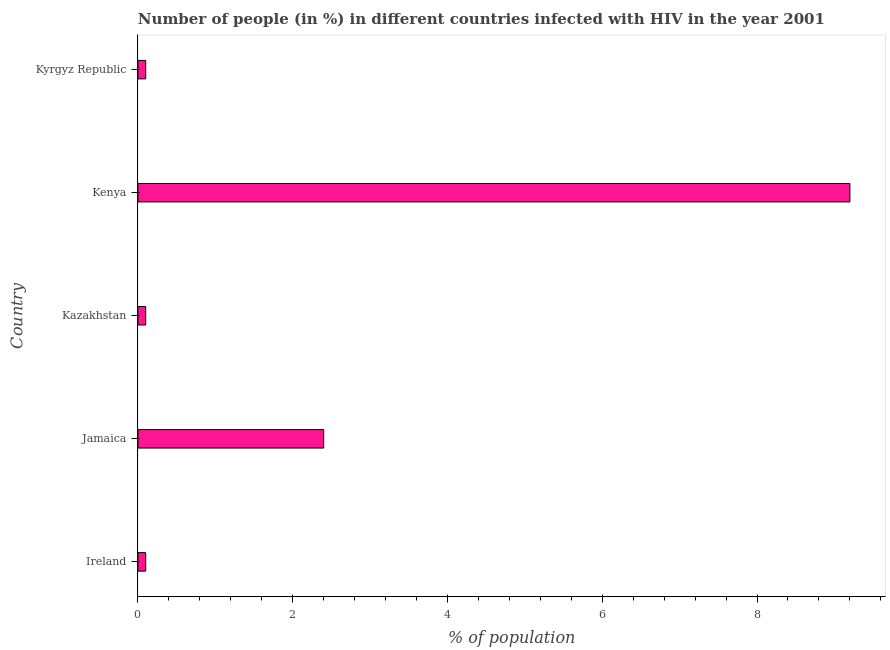What is the title of the graph?
Ensure brevity in your answer.  Number of people (in %) in different countries infected with HIV in the year 2001. What is the label or title of the X-axis?
Make the answer very short. % of population. What is the label or title of the Y-axis?
Make the answer very short. Country. What is the number of people infected with hiv in Kenya?
Your answer should be very brief. 9.2. Across all countries, what is the maximum number of people infected with hiv?
Ensure brevity in your answer.  9.2. In which country was the number of people infected with hiv maximum?
Your answer should be very brief. Kenya. In which country was the number of people infected with hiv minimum?
Give a very brief answer. Ireland. What is the sum of the number of people infected with hiv?
Offer a terse response. 11.9. What is the difference between the number of people infected with hiv in Ireland and Kazakhstan?
Your answer should be very brief. 0. What is the average number of people infected with hiv per country?
Offer a very short reply. 2.38. What is the median number of people infected with hiv?
Your response must be concise. 0.1. In how many countries, is the number of people infected with hiv greater than 5.6 %?
Provide a short and direct response. 1. What is the ratio of the number of people infected with hiv in Jamaica to that in Kazakhstan?
Your answer should be compact. 24. Is the difference between the number of people infected with hiv in Jamaica and Kyrgyz Republic greater than the difference between any two countries?
Make the answer very short. No. What is the difference between the highest and the second highest number of people infected with hiv?
Ensure brevity in your answer.  6.8. What is the difference between the highest and the lowest number of people infected with hiv?
Your response must be concise. 9.1. How many countries are there in the graph?
Provide a short and direct response. 5. What is the difference between two consecutive major ticks on the X-axis?
Your answer should be very brief. 2. What is the % of population of Ireland?
Your response must be concise. 0.1. What is the % of population of Kenya?
Give a very brief answer. 9.2. What is the % of population in Kyrgyz Republic?
Provide a short and direct response. 0.1. What is the difference between the % of population in Ireland and Kyrgyz Republic?
Ensure brevity in your answer.  0. What is the difference between the % of population in Jamaica and Kenya?
Offer a terse response. -6.8. What is the difference between the % of population in Jamaica and Kyrgyz Republic?
Make the answer very short. 2.3. What is the ratio of the % of population in Ireland to that in Jamaica?
Ensure brevity in your answer.  0.04. What is the ratio of the % of population in Ireland to that in Kenya?
Provide a succinct answer. 0.01. What is the ratio of the % of population in Ireland to that in Kyrgyz Republic?
Your response must be concise. 1. What is the ratio of the % of population in Jamaica to that in Kenya?
Your answer should be compact. 0.26. What is the ratio of the % of population in Kazakhstan to that in Kenya?
Your answer should be compact. 0.01. What is the ratio of the % of population in Kenya to that in Kyrgyz Republic?
Keep it short and to the point. 92. 